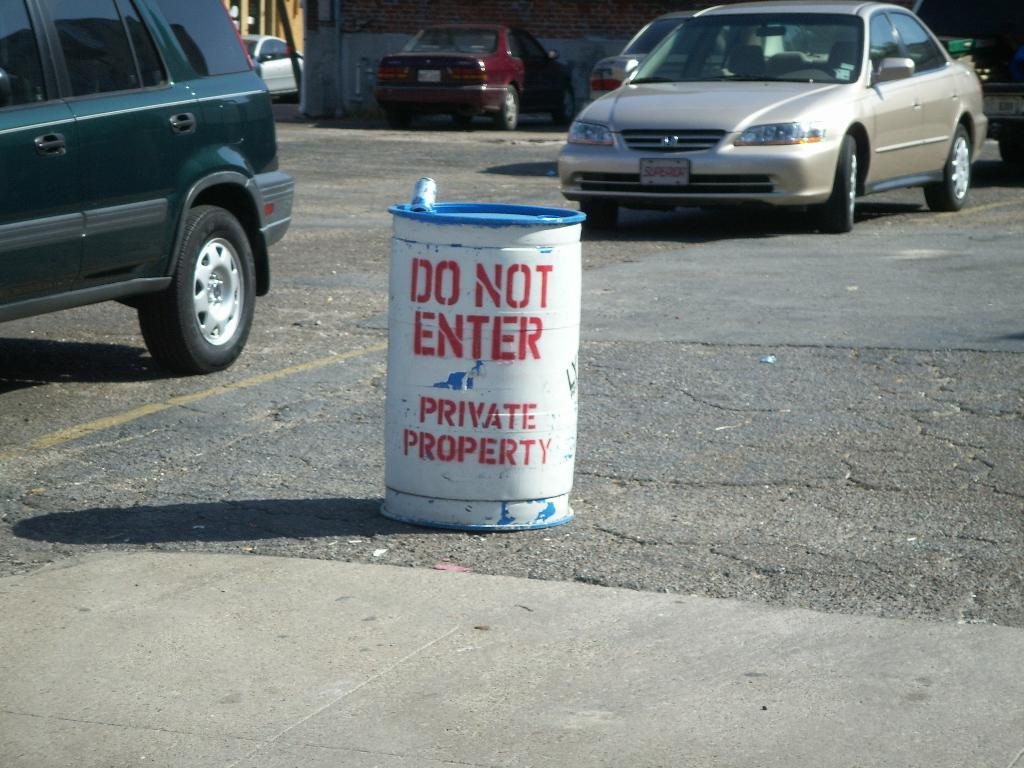<image>
Summarize the visual content of the image. A white barrel in a parking lot has DO NOT ENTER spray painted in red stencil letters. 